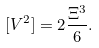<formula> <loc_0><loc_0><loc_500><loc_500>[ V ^ { 2 } ] = 2 \frac { \Xi ^ { 3 } } { 6 } .</formula> 